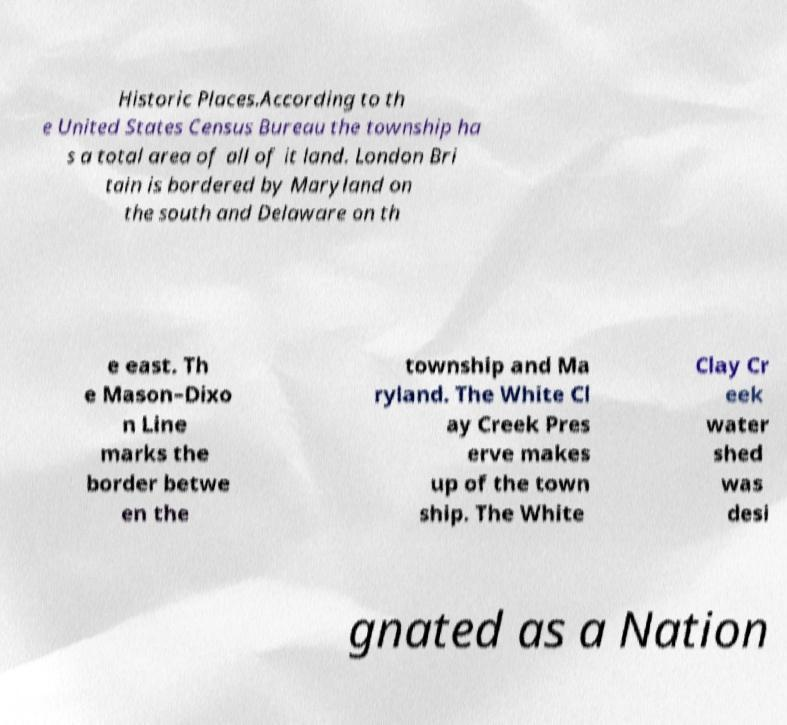What messages or text are displayed in this image? I need them in a readable, typed format. Historic Places.According to th e United States Census Bureau the township ha s a total area of all of it land. London Bri tain is bordered by Maryland on the south and Delaware on th e east. Th e Mason–Dixo n Line marks the border betwe en the township and Ma ryland. The White Cl ay Creek Pres erve makes up of the town ship. The White Clay Cr eek water shed was desi gnated as a Nation 